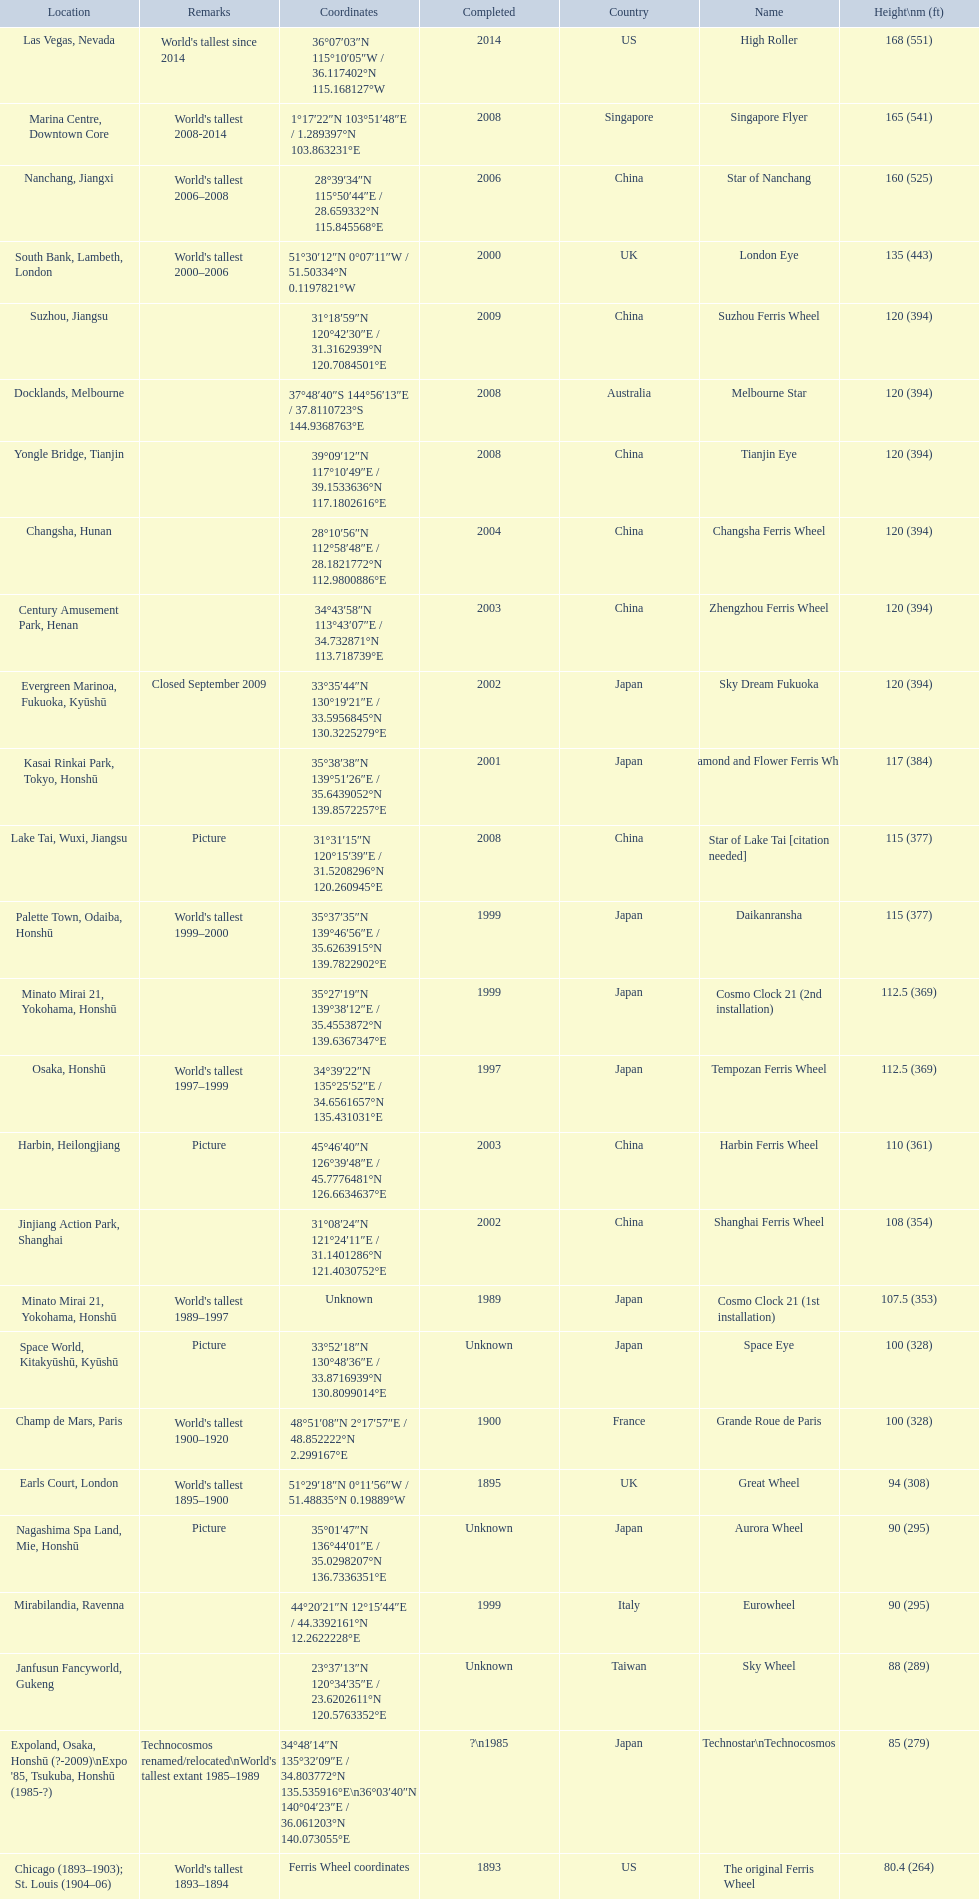What are all of the ferris wheel names? High Roller, Singapore Flyer, Star of Nanchang, London Eye, Suzhou Ferris Wheel, Melbourne Star, Tianjin Eye, Changsha Ferris Wheel, Zhengzhou Ferris Wheel, Sky Dream Fukuoka, Diamond and Flower Ferris Wheel, Star of Lake Tai [citation needed], Daikanransha, Cosmo Clock 21 (2nd installation), Tempozan Ferris Wheel, Harbin Ferris Wheel, Shanghai Ferris Wheel, Cosmo Clock 21 (1st installation), Space Eye, Grande Roue de Paris, Great Wheel, Aurora Wheel, Eurowheel, Sky Wheel, Technostar\nTechnocosmos, The original Ferris Wheel. What was the height of each one? 168 (551), 165 (541), 160 (525), 135 (443), 120 (394), 120 (394), 120 (394), 120 (394), 120 (394), 120 (394), 117 (384), 115 (377), 115 (377), 112.5 (369), 112.5 (369), 110 (361), 108 (354), 107.5 (353), 100 (328), 100 (328), 94 (308), 90 (295), 90 (295), 88 (289), 85 (279), 80.4 (264). And when were they completed? 2014, 2008, 2006, 2000, 2009, 2008, 2008, 2004, 2003, 2002, 2001, 2008, 1999, 1999, 1997, 2003, 2002, 1989, Unknown, 1900, 1895, Unknown, 1999, Unknown, ?\n1985, 1893. Which were completed in 2008? Singapore Flyer, Melbourne Star, Tianjin Eye, Star of Lake Tai [citation needed]. And of those ferris wheels, which had a height of 165 meters? Singapore Flyer. 